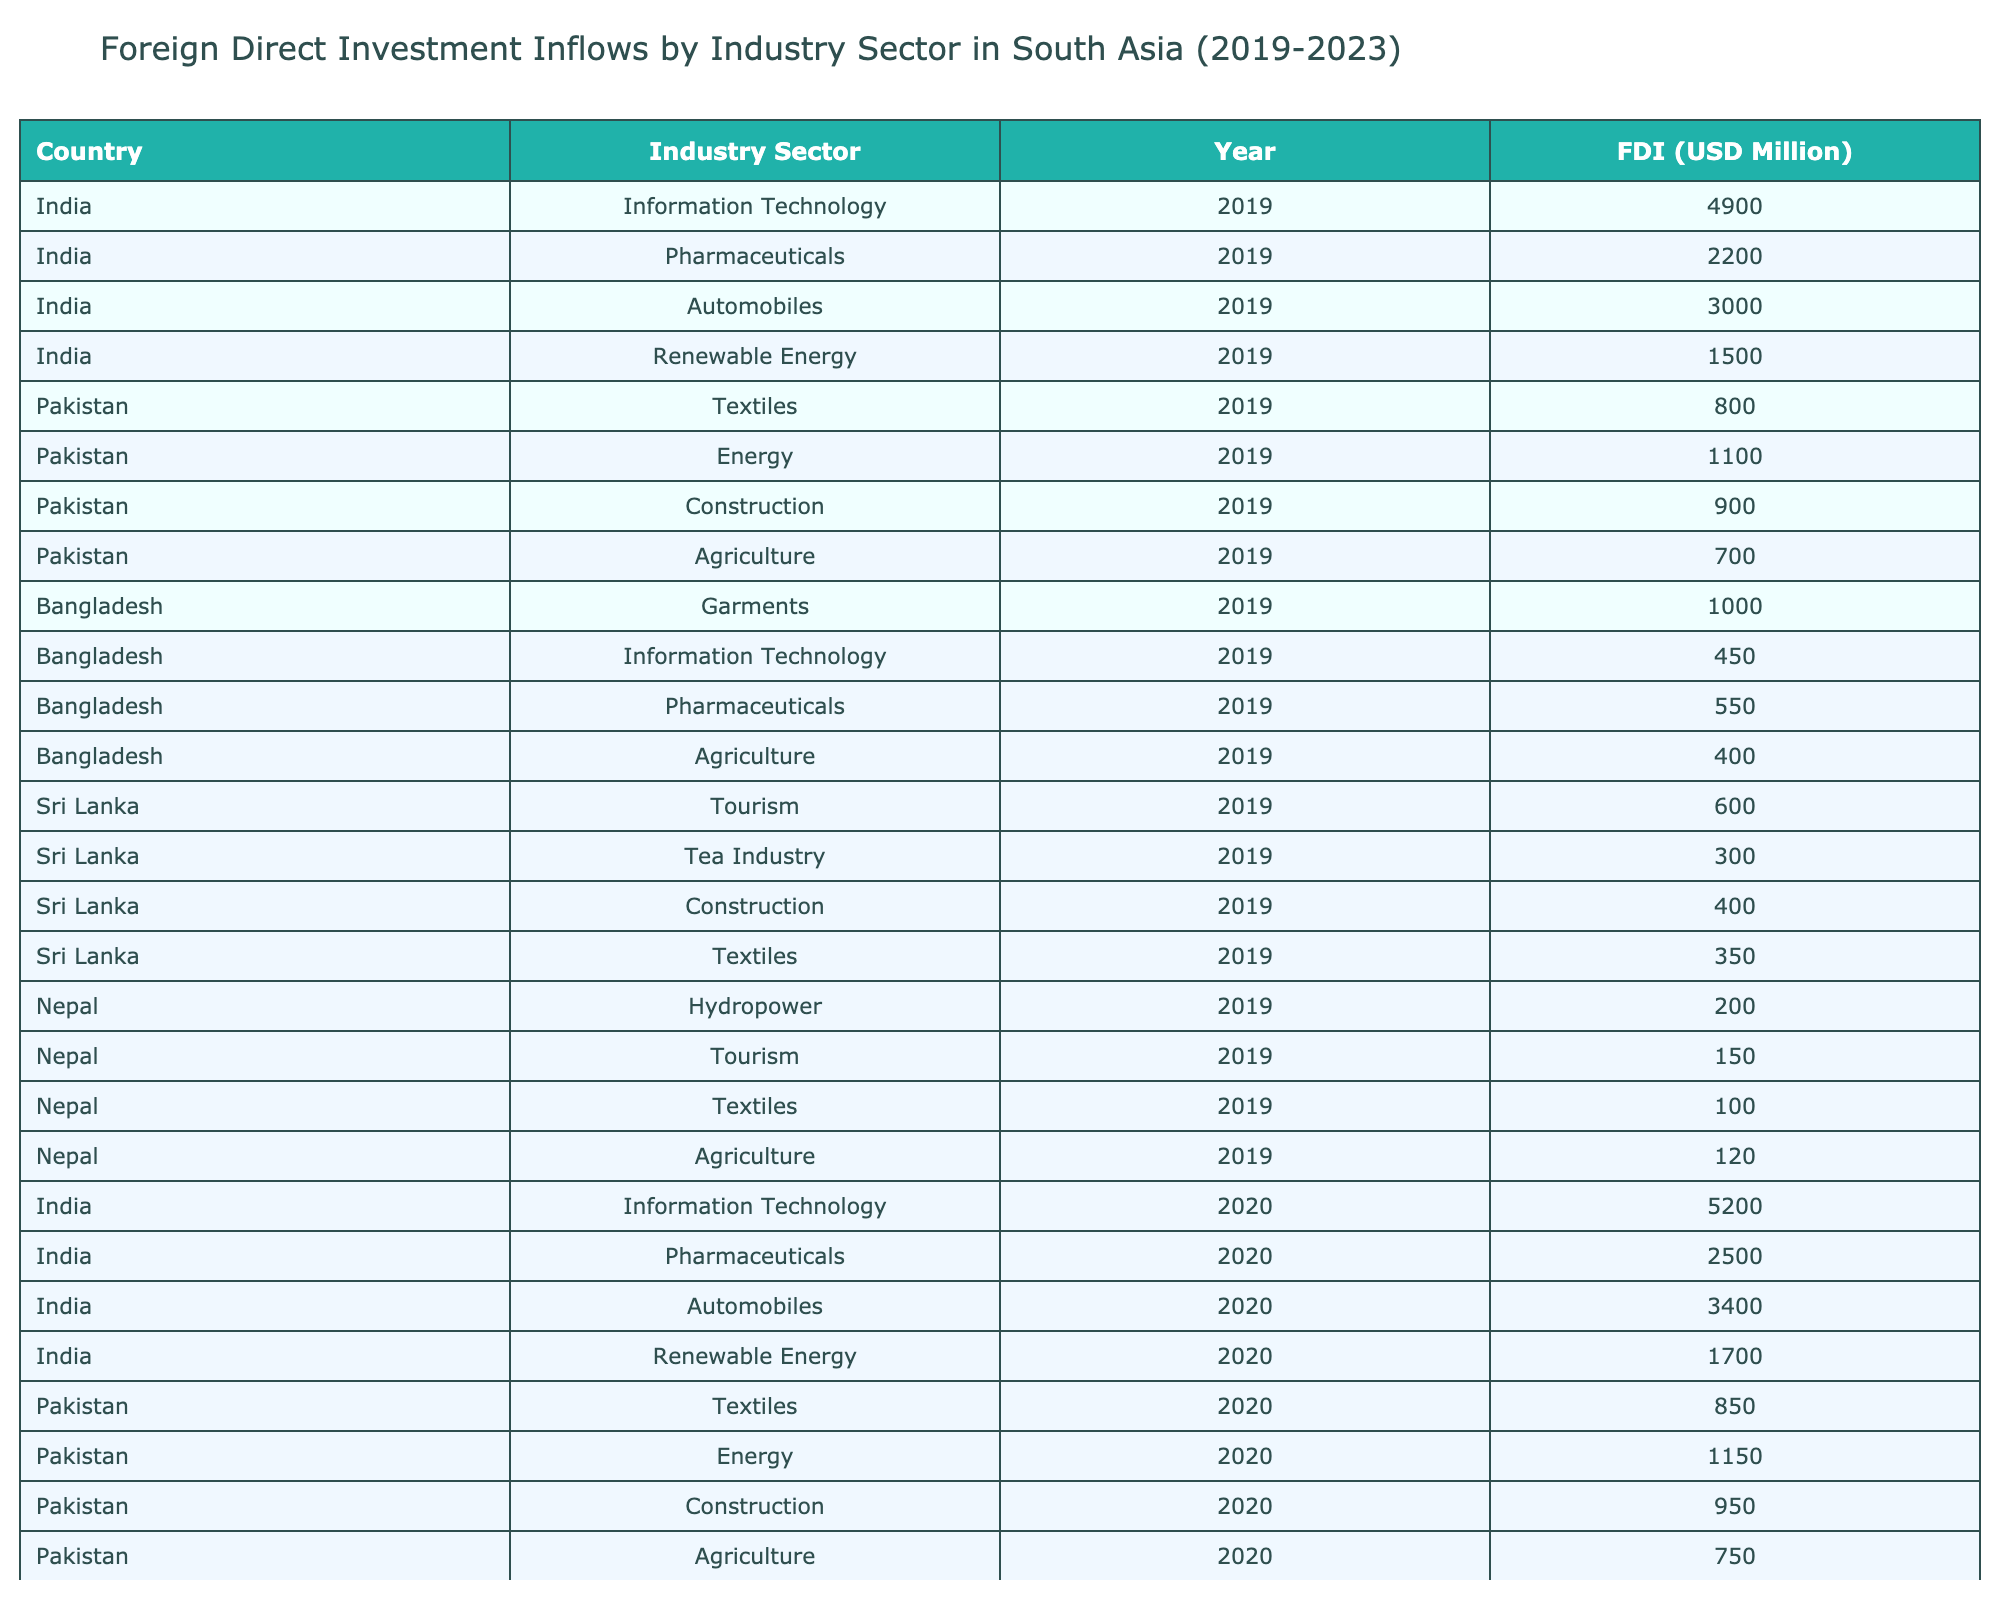What was the highest Foreign Direct Investment inflow for Information Technology in India during the period? The highest Foreign Direct Investment inflow for Information Technology in India is visible in the year 2023, which amounts to 6700 million USD, as listed in the table.
Answer: 6700 Which sector received the least FDI in Nepal in 2023? In 2023, the sector with the least Foreign Direct Investment inflow in Nepal is Textiles, with an inflow of 140 million USD, as per the table data.
Answer: Textiles What was the average FDI inflow for the Pharmaceuticals sector in India from 2019 to 2023? The inflows for Pharmaceuticals in India from 2019 to 2023 are 2200, 2500, 2700, 2900, and 3100 million USD. Adding them gives 2200 + 2500 + 2700 + 2900 + 3100 = 14400 million USD. Dividing by 5 gives an average of 14400 / 5 = 2880 million USD.
Answer: 2880 Did Bangladesh see an increase in FDI for Agriculture from 2019 to 2023? The inflow for Agriculture in Bangladesh increased from 400 million USD in 2019 to 510 million USD in 2023, thus confirming an increase in FDI for this sector.
Answer: Yes What is the total FDI inflow for the Energy sector in Pakistan from 2019 to 2023? The FDI inflows for the Energy sector in Pakistan from 2019 to 2023 are: 1100 (2019) + 1150 (2020) + 1200 (2021) + 1260 (2022) + 1320 (2023) = 6130 million USD. Thus, the total inflow is 6130 million USD.
Answer: 6130 Which country had the highest FDI inflow for the Automobiles sector in 2022 and what was the amount? The table shows that India had the highest FDI inflow for the Automobiles sector in 2022, with an inflow of 3900 million USD. Therefore, the answer is India with 3900 million USD.
Answer: India, 3900 What was the percentage increase in FDI for the Tea Industry in Sri Lanka from 2019 to 2023? The FDI for Tea Industry in Sri Lanka increased from 300 million USD in 2019 to 380 million USD in 2023. The increase is 380 - 300 = 80 million USD. To find the percentage increase: (80 / 300) * 100 = 26.67%. Thus, the percentage increase is approximately 26.67%.
Answer: 26.67% Was the FDI inflow for Construction in Pakistan higher than in Sri Lanka in 2021? In 2021, Pakistan's FDI inflow for Construction was 1000 million USD, while Sri Lanka's was 440 million USD. Since 1000 million USD is greater than 440 million USD, the answer is yes.
Answer: Yes 